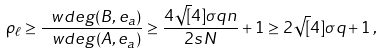<formula> <loc_0><loc_0><loc_500><loc_500>\rho _ { \ell } \geq \frac { \ w d e g ( B , e _ { a } ) } { \ w d e g ( A , e _ { a } ) } \geq \frac { 4 \sqrt { [ } 4 ] { \sigma } q n } { 2 s N } + 1 \geq 2 \sqrt { [ } 4 ] { \sigma } q + 1 \, ,</formula> 